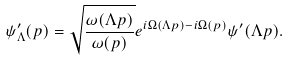<formula> <loc_0><loc_0><loc_500><loc_500>\psi _ { \Lambda } ^ { \prime } ( { p } ) = \sqrt { \frac { \omega ( { \Lambda p } ) } { \omega ( { p } ) } } e ^ { i \Omega ( { \Lambda p } ) - i \Omega ( { p } ) } \psi ^ { \prime } ( { \Lambda p } ) .</formula> 